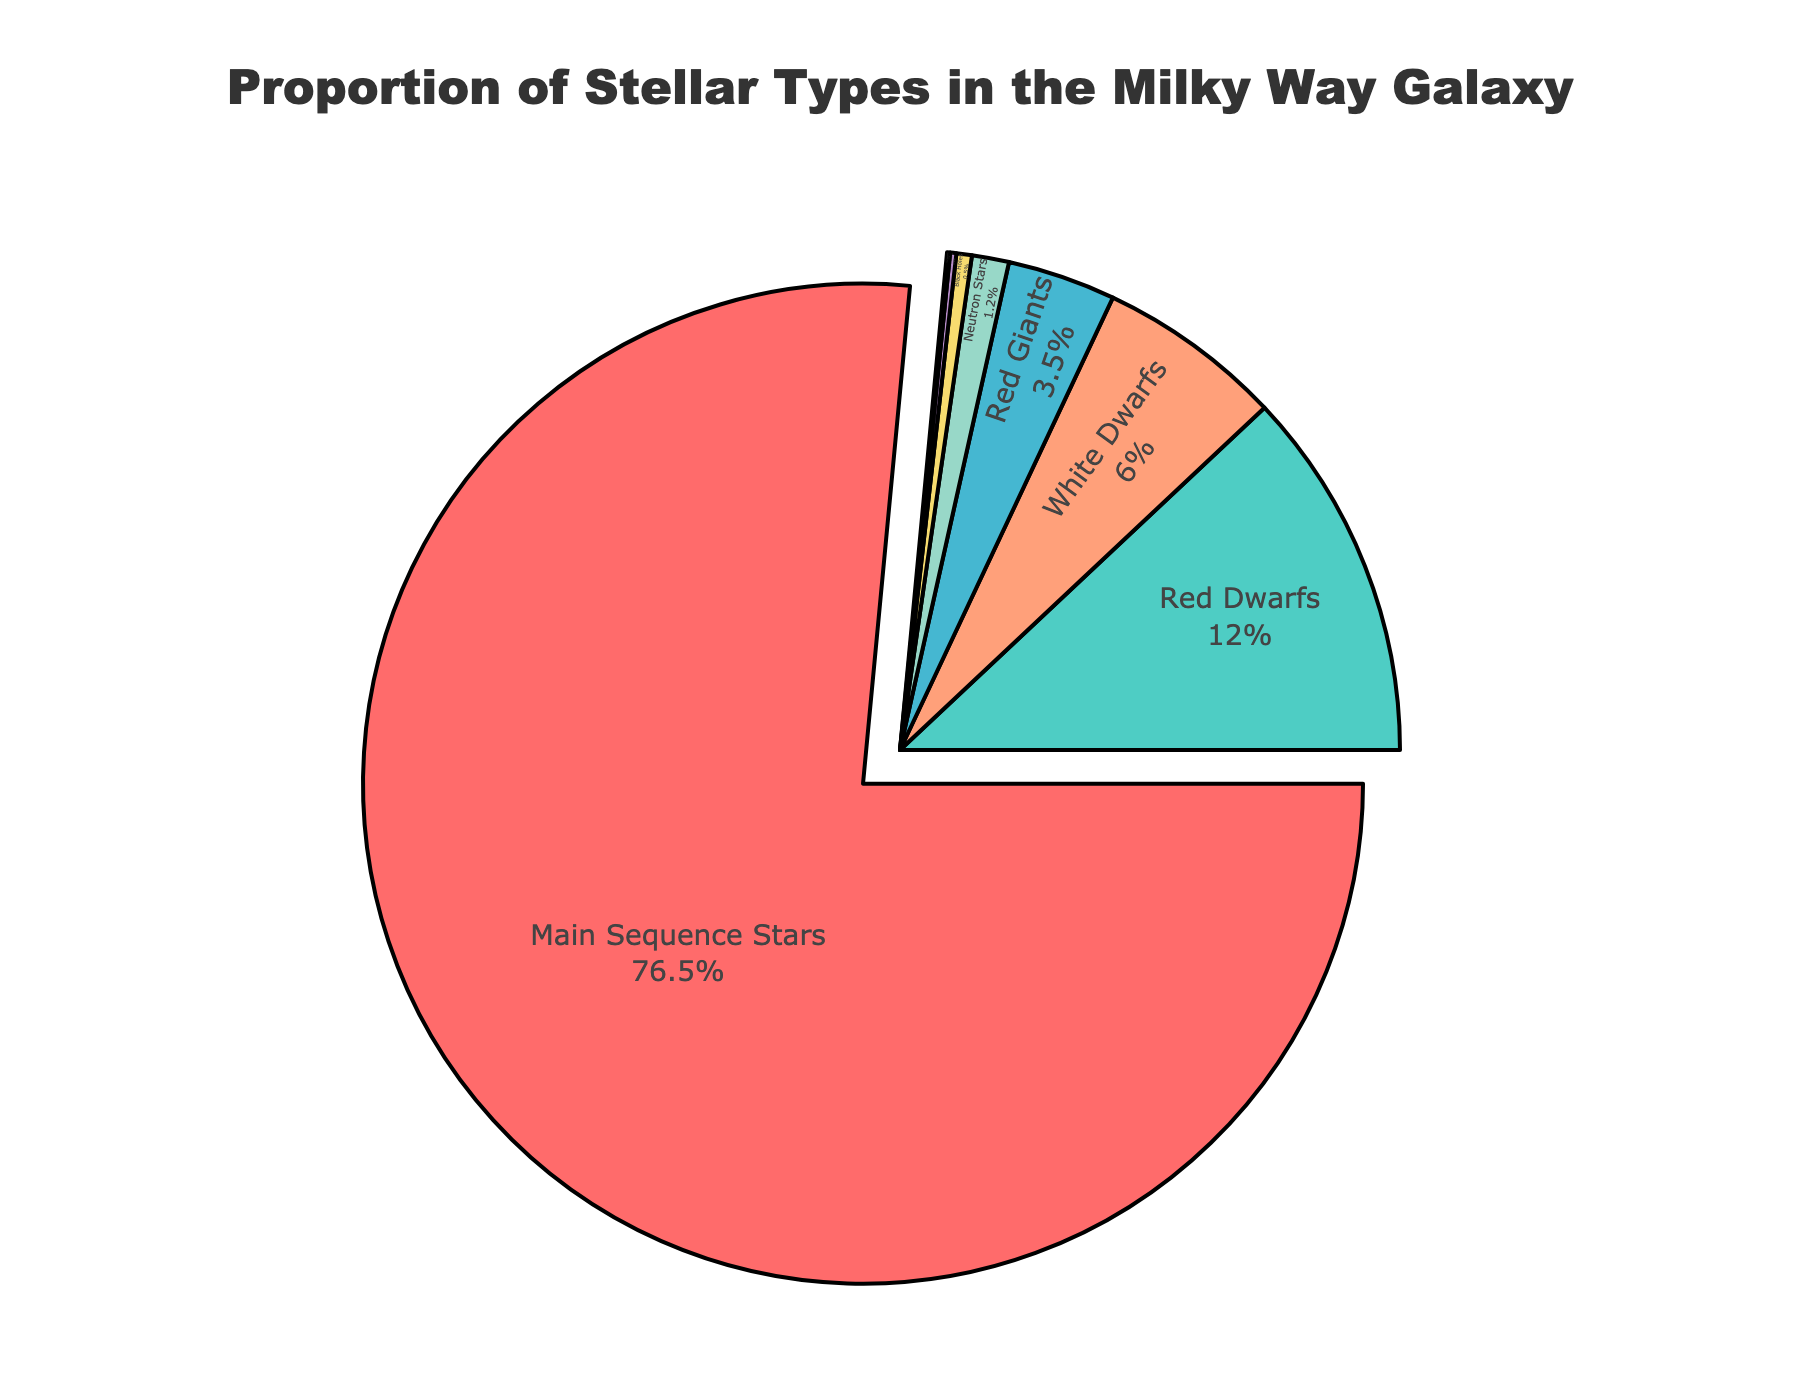What's the most common type of star in the Milky Way? The largest section of the pie chart is labeled "Main Sequence Stars" with 76.5%. This indicates that Main Sequence Stars are the most common type.
Answer: Main Sequence Stars What is the combined percentage of Red Dwarfs and Red Giants in the Milky Way? To find the total percentage of Red Dwarfs and Red Giants, add their individual percentages: 12.0% (Red Dwarfs) + 3.5% (Red Giants) = 15.5%.
Answer: 15.5% Which stellar type is represented by the smallest section in the pie chart? The smallest section of the pie chart is labeled “Blue Supergiants” with 0.1%, making it the smallest proportion of stellar types shown.
Answer: Blue Supergiants How much more common are Main Sequence Stars compared to White Dwarfs? Subtract the percentage of White Dwarfs from the percentage of Main Sequence Stars: 76.5% - 6.0% = 70.5%.
Answer: 70.5% Which stellar type, other than Main Sequence Stars, has the largest proportion? The second-largest section in the pie chart, after Main Sequence Stars, is labeled “Red Dwarfs” with 12.0%.
Answer: Red Dwarfs What is the total percentage of Neutron Stars and Black Holes combined? Add the percentages of Neutron Stars and Black Holes together: 1.2% (Neutron Stars) + 0.5% (Black Holes) = 1.7%.
Answer: 1.7% Are there more Red Giants or White Dwarfs? Compare the percentages: Red Giants have 3.5% and White Dwarfs have 6.0%. White Dwarfs have a larger proportion than Red Giants.
Answer: White Dwarfs Which section of the pie chart is colored red? Observe the colors in the pie chart and their labels. The section labeled “Main Sequence Stars” is colored red.
Answer: Main Sequence Stars 